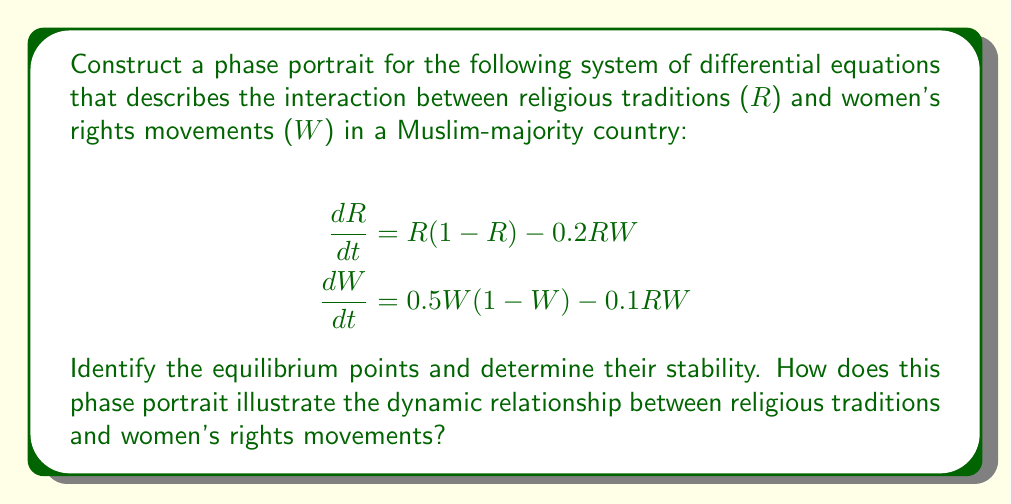Help me with this question. 1. Find the equilibrium points by setting both equations to zero:

   $$R(1-R) - 0.2RW = 0$$
   $$0.5W(1-W) - 0.1RW = 0$$

2. Solve the system:
   a) Trivial equilibrium: (0,0)
   b) Religious dominance: (1,0)
   c) Women's rights dominance: (0,1)
   d) Coexistence equilibrium: Solve simultaneously
      $$1-R-0.2W = 0$$
      $$0.5-0.5W-0.1R = 0$$
      This yields: (R*,W*) ≈ (0.714, 1.429)

3. Analyze stability by finding the Jacobian matrix:

   $$J = \begin{bmatrix}
   1-2R-0.2W & -0.2R \\
   -0.1W & 0.5-W-0.1R
   \end{bmatrix}$$

4. Evaluate eigenvalues at each equilibrium point:
   a) (0,0): λ₁ = 1, λ₂ = 0.5 (Unstable node)
   b) (1,0): λ₁ = -1, λ₂ = 0.4 (Saddle point)
   c) (0,1): λ₁ = 0.8, λ₂ = -0.5 (Saddle point)
   d) (0.714, 1.429): Both eigenvalues have negative real parts (Stable focus)

5. Sketch the phase portrait:

[asy]
import graph;
size(200);

// Define vector field function
pair F(pair z) {
  real x = z.x, y = z.y;
  return (x*(1-x)-0.2*x*y, 0.5*y*(1-y)-0.1*x*y);
}

// Draw vector field
vectorfield(F, (0,0), (1.5,1.5), green, 0.7);

// Draw nullclines
draw((0,0)--(1,0)--(1,5), blue);
draw((0,0)--(0,1)--(5,1), red);

// Mark equilibrium points
dot((0,0), red);
dot((1,0), red);
dot((0,1), red);
dot((0.714,1.429), red);

// Label equilibrium points
label("(0,0)", (0,0), SW);
label("(1,0)", (1,0), SE);
label("(0,1)", (0,1), NW);
label("(R*,W*)", (0.714,1.429), NE);

// Label axes
label("R", (1.5,0), E);
label("W", (0,1.5), N);
[/asy]

The phase portrait illustrates:
1. The unstable node at (0,0) shows that both religious traditions and women's rights movements tend to grow from zero.
2. Saddle points at (1,0) and (0,1) indicate that complete dominance of either religious traditions or women's rights is unstable.
3. The stable focus at (R*,W*) suggests a long-term coexistence between religious traditions and women's rights movements, with some oscillation as they approach equilibrium.
4. Trajectories spiral towards the stable focus, showing how the interaction between religious traditions and women's rights movements can lead to a balanced state over time.
Answer: The phase portrait shows four equilibrium points: unstable node (0,0), saddle points (1,0) and (0,1), and stable focus (0.714, 1.429). It illustrates a dynamic relationship where religious traditions and women's rights movements coexist and stabilize over time. 